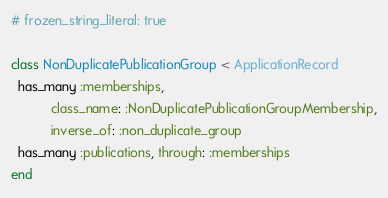<code> <loc_0><loc_0><loc_500><loc_500><_Ruby_># frozen_string_literal: true

class NonDuplicatePublicationGroup < ApplicationRecord
  has_many :memberships,
           class_name: :NonDuplicatePublicationGroupMembership,
           inverse_of: :non_duplicate_group
  has_many :publications, through: :memberships
end
</code> 